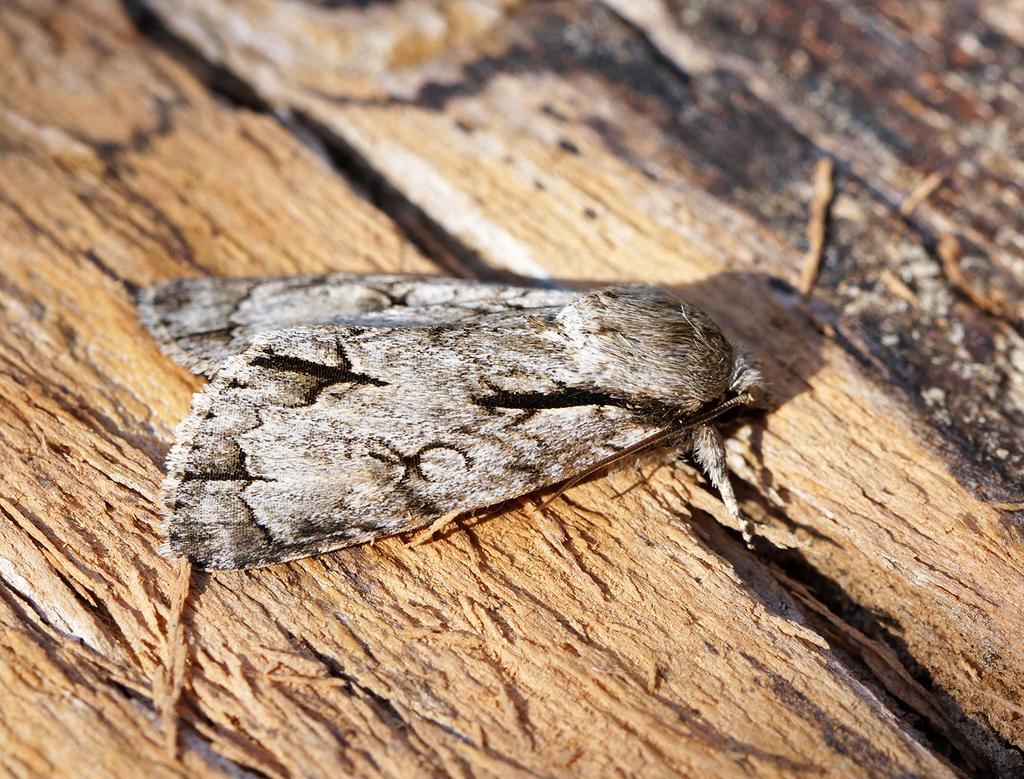In one or two sentences, can you explain what this image depicts? In this picture we can see an insect on a wooden surface. 